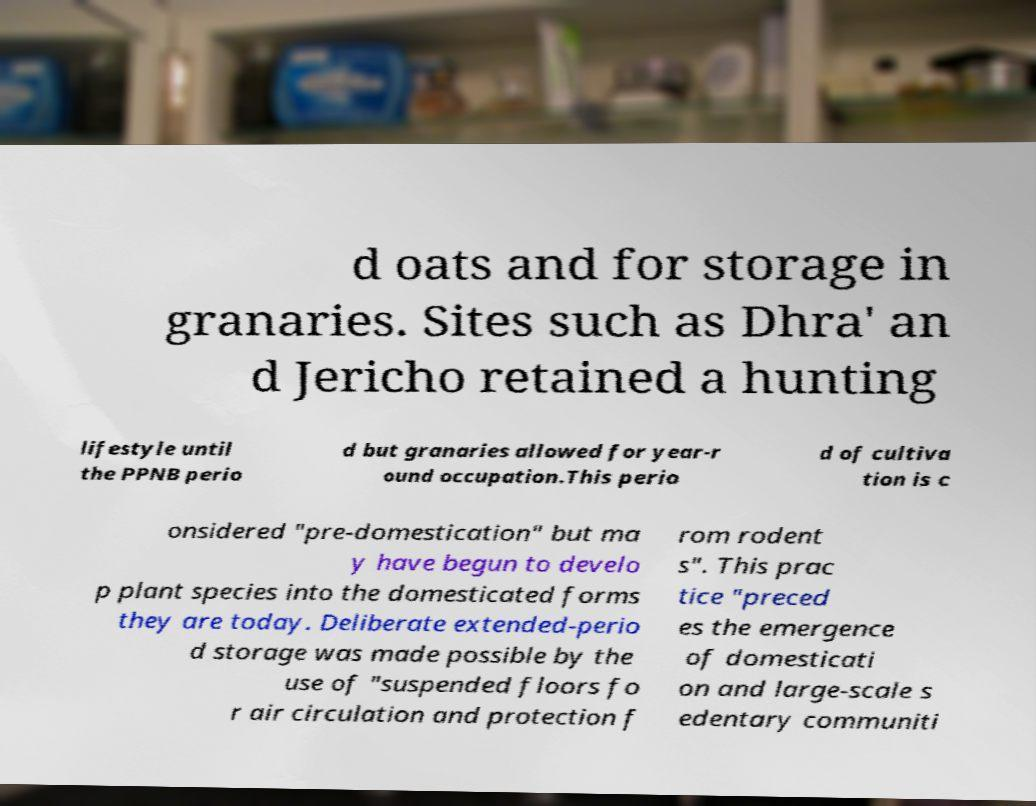What messages or text are displayed in this image? I need them in a readable, typed format. d oats and for storage in granaries. Sites such as Dhra′ an d Jericho retained a hunting lifestyle until the PPNB perio d but granaries allowed for year-r ound occupation.This perio d of cultiva tion is c onsidered "pre-domestication" but ma y have begun to develo p plant species into the domesticated forms they are today. Deliberate extended-perio d storage was made possible by the use of "suspended floors fo r air circulation and protection f rom rodent s". This prac tice "preced es the emergence of domesticati on and large-scale s edentary communiti 